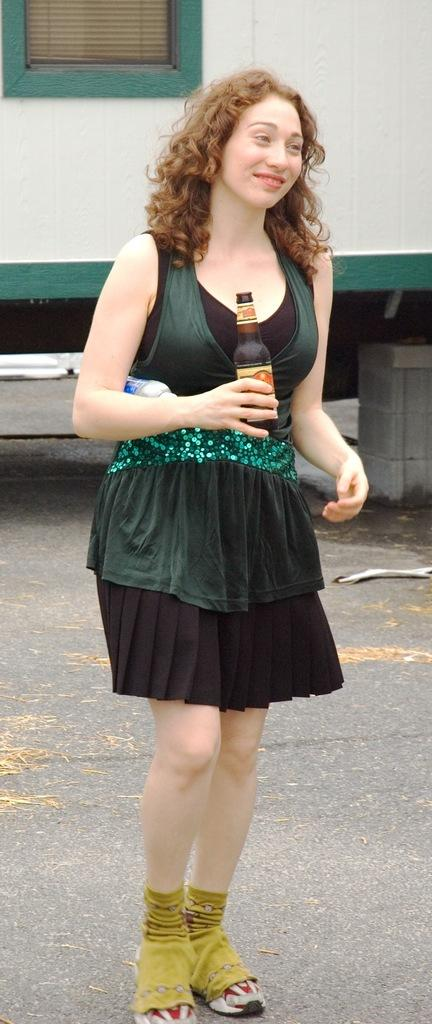Who is the main subject in the image? There is a woman in the image. What is the woman doing in the image? The woman is standing in the image. What is the woman holding in her hand? The woman is holding a wine bottle in her hand. What color is the dress the woman is wearing? The woman is wearing a green color dress. Is the woman standing near a stream in the image? There is no stream present in the image. 